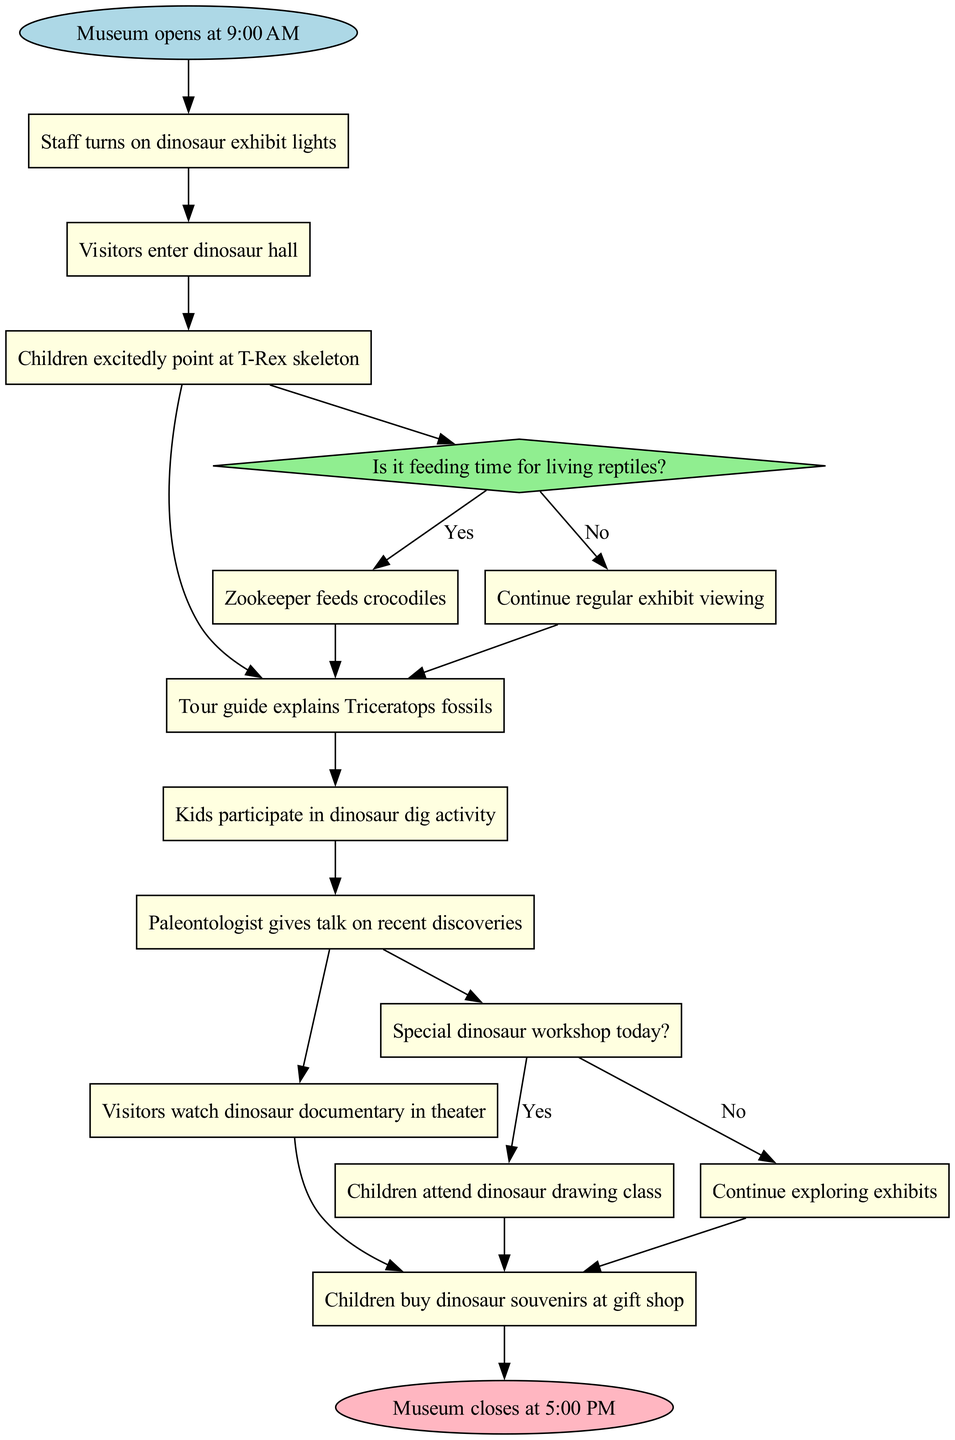What time does the museum open? The diagram indicates the initial node which states "Museum opens at 9:00 AM." This provides the exact opening time of the museum.
Answer: 9:00 AM How many activities are there in total? The diagram lists eight activities in the activities section. By counting them, we can deduce that the number of activities is eight.
Answer: 8 What is the second activity listed? The diagram shows the activities in a sequence. By examining the list, the second activity after the museum opens is "Visitors enter dinosaur hall."
Answer: Visitors enter dinosaur hall What happens if it is not feeding time for living reptiles? The decision labeled "Is it feeding time for living reptiles?" leads to a "No" response which states "Continue regular exhibit viewing." This indicates the alternative action if it is not feeding time.
Answer: Continue regular exhibit viewing What is the final activity before the museum closes? The diagram outlines the activities and the last one listed before the final node (museum closing) is "Children buy dinosaur souvenirs at gift shop." This is the last activity before closing time.
Answer: Children buy dinosaur souvenirs at gift shop What type of node connects "Tour guide explains Triceratops fossils" and the decision about feeding time? The edge from the activity "Tour guide explains Triceratops fossils" connects to a diamond shape node, which represents a decision. Specifically, it leads to the decision node "Is it feeding time for living reptiles?"
Answer: Decision If there is a special dinosaur workshop, what do children attend? The decision "Special dinosaur workshop today?" leads to a "Yes" response that states "Children attend dinosaur drawing class." This describes the outcome if the workshop is taking place.
Answer: Children attend dinosaur drawing class What is the color of the nodes representing activities? The diagram specifies that activities are represented in rectangle-shaped nodes filled with light yellow color. This visual feature defines the type of node used for activities.
Answer: Light yellow 